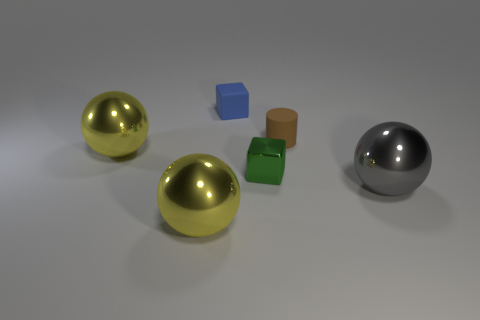If you were to arrange these objects by weight, which order would you choose? Assuming the objects are made from materials as they visually appear, the golden spheres would likely be the heaviest, assuming they are solid, followed by the metallic-looking sphere, the green cube, the brown cylinder, and finally the small blue object, which might be the lightest if it's made of paper or a similar light material. 